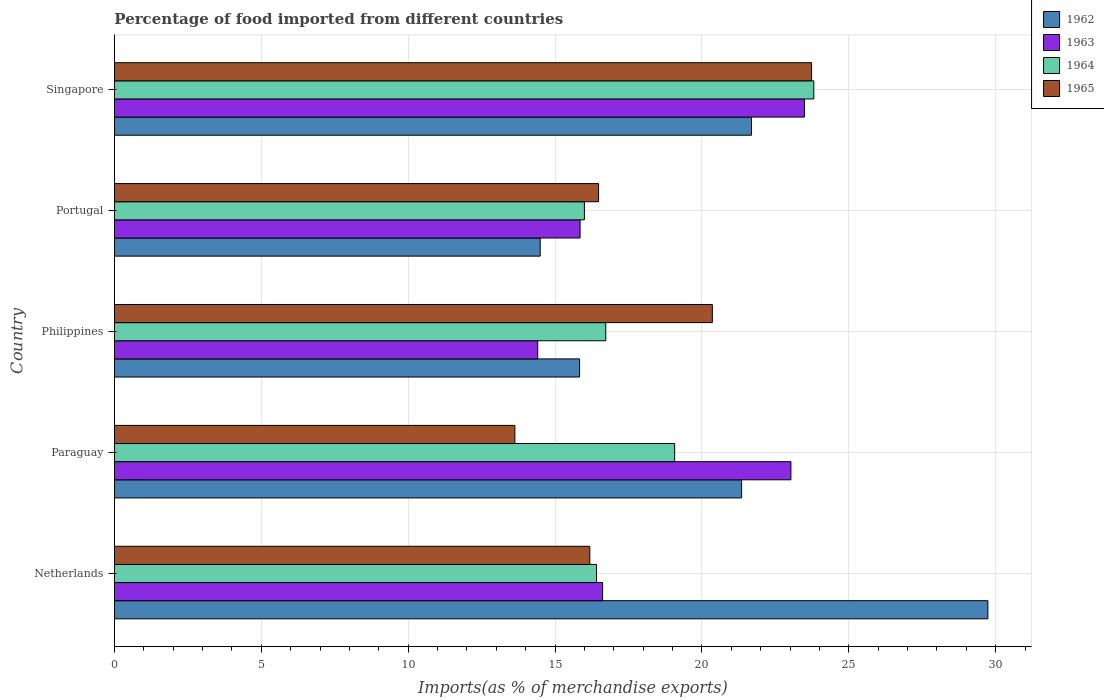How many different coloured bars are there?
Ensure brevity in your answer.  4. In how many cases, is the number of bars for a given country not equal to the number of legend labels?
Offer a very short reply. 0. What is the percentage of imports to different countries in 1964 in Paraguay?
Ensure brevity in your answer.  19.07. Across all countries, what is the maximum percentage of imports to different countries in 1963?
Make the answer very short. 23.49. Across all countries, what is the minimum percentage of imports to different countries in 1963?
Give a very brief answer. 14.41. In which country was the percentage of imports to different countries in 1965 minimum?
Your answer should be compact. Paraguay. What is the total percentage of imports to different countries in 1962 in the graph?
Provide a succinct answer. 103.1. What is the difference between the percentage of imports to different countries in 1963 in Philippines and that in Singapore?
Your answer should be compact. -9.08. What is the difference between the percentage of imports to different countries in 1962 in Paraguay and the percentage of imports to different countries in 1965 in Singapore?
Offer a very short reply. -2.38. What is the average percentage of imports to different countries in 1963 per country?
Your answer should be compact. 18.68. What is the difference between the percentage of imports to different countries in 1963 and percentage of imports to different countries in 1964 in Paraguay?
Provide a succinct answer. 3.96. In how many countries, is the percentage of imports to different countries in 1965 greater than 14 %?
Give a very brief answer. 4. What is the ratio of the percentage of imports to different countries in 1962 in Portugal to that in Singapore?
Your answer should be compact. 0.67. Is the percentage of imports to different countries in 1964 in Netherlands less than that in Portugal?
Your answer should be compact. No. Is the difference between the percentage of imports to different countries in 1963 in Netherlands and Philippines greater than the difference between the percentage of imports to different countries in 1964 in Netherlands and Philippines?
Keep it short and to the point. Yes. What is the difference between the highest and the second highest percentage of imports to different countries in 1963?
Provide a short and direct response. 0.46. What is the difference between the highest and the lowest percentage of imports to different countries in 1965?
Provide a succinct answer. 10.1. In how many countries, is the percentage of imports to different countries in 1962 greater than the average percentage of imports to different countries in 1962 taken over all countries?
Your answer should be very brief. 3. Is it the case that in every country, the sum of the percentage of imports to different countries in 1964 and percentage of imports to different countries in 1963 is greater than the sum of percentage of imports to different countries in 1965 and percentage of imports to different countries in 1962?
Your answer should be very brief. No. What does the 1st bar from the top in Paraguay represents?
Provide a short and direct response. 1965. What does the 4th bar from the bottom in Paraguay represents?
Your response must be concise. 1965. How many bars are there?
Provide a succinct answer. 20. Are all the bars in the graph horizontal?
Your answer should be very brief. Yes. What is the difference between two consecutive major ticks on the X-axis?
Provide a succinct answer. 5. Does the graph contain any zero values?
Provide a short and direct response. No. Does the graph contain grids?
Offer a terse response. Yes. Where does the legend appear in the graph?
Offer a terse response. Top right. What is the title of the graph?
Your response must be concise. Percentage of food imported from different countries. What is the label or title of the X-axis?
Provide a short and direct response. Imports(as % of merchandise exports). What is the label or title of the Y-axis?
Provide a succinct answer. Country. What is the Imports(as % of merchandise exports) in 1962 in Netherlands?
Your answer should be compact. 29.73. What is the Imports(as % of merchandise exports) of 1963 in Netherlands?
Ensure brevity in your answer.  16.62. What is the Imports(as % of merchandise exports) of 1964 in Netherlands?
Offer a very short reply. 16.41. What is the Imports(as % of merchandise exports) of 1965 in Netherlands?
Give a very brief answer. 16.18. What is the Imports(as % of merchandise exports) in 1962 in Paraguay?
Give a very brief answer. 21.35. What is the Imports(as % of merchandise exports) in 1963 in Paraguay?
Ensure brevity in your answer.  23.03. What is the Imports(as % of merchandise exports) of 1964 in Paraguay?
Give a very brief answer. 19.07. What is the Imports(as % of merchandise exports) in 1965 in Paraguay?
Provide a succinct answer. 13.63. What is the Imports(as % of merchandise exports) in 1962 in Philippines?
Your answer should be very brief. 15.83. What is the Imports(as % of merchandise exports) of 1963 in Philippines?
Provide a succinct answer. 14.41. What is the Imports(as % of merchandise exports) in 1964 in Philippines?
Give a very brief answer. 16.73. What is the Imports(as % of merchandise exports) in 1965 in Philippines?
Provide a short and direct response. 20.35. What is the Imports(as % of merchandise exports) of 1962 in Portugal?
Make the answer very short. 14.49. What is the Imports(as % of merchandise exports) of 1963 in Portugal?
Your response must be concise. 15.85. What is the Imports(as % of merchandise exports) in 1964 in Portugal?
Keep it short and to the point. 16. What is the Imports(as % of merchandise exports) of 1965 in Portugal?
Offer a very short reply. 16.48. What is the Imports(as % of merchandise exports) of 1962 in Singapore?
Provide a succinct answer. 21.69. What is the Imports(as % of merchandise exports) of 1963 in Singapore?
Your answer should be compact. 23.49. What is the Imports(as % of merchandise exports) of 1964 in Singapore?
Offer a terse response. 23.81. What is the Imports(as % of merchandise exports) in 1965 in Singapore?
Your response must be concise. 23.73. Across all countries, what is the maximum Imports(as % of merchandise exports) of 1962?
Provide a succinct answer. 29.73. Across all countries, what is the maximum Imports(as % of merchandise exports) in 1963?
Your response must be concise. 23.49. Across all countries, what is the maximum Imports(as % of merchandise exports) in 1964?
Your response must be concise. 23.81. Across all countries, what is the maximum Imports(as % of merchandise exports) of 1965?
Your response must be concise. 23.73. Across all countries, what is the minimum Imports(as % of merchandise exports) of 1962?
Keep it short and to the point. 14.49. Across all countries, what is the minimum Imports(as % of merchandise exports) in 1963?
Keep it short and to the point. 14.41. Across all countries, what is the minimum Imports(as % of merchandise exports) in 1964?
Give a very brief answer. 16. Across all countries, what is the minimum Imports(as % of merchandise exports) in 1965?
Provide a succinct answer. 13.63. What is the total Imports(as % of merchandise exports) of 1962 in the graph?
Your response must be concise. 103.1. What is the total Imports(as % of merchandise exports) in 1963 in the graph?
Your response must be concise. 93.4. What is the total Imports(as % of merchandise exports) in 1964 in the graph?
Keep it short and to the point. 92.02. What is the total Imports(as % of merchandise exports) in 1965 in the graph?
Your answer should be compact. 90.38. What is the difference between the Imports(as % of merchandise exports) in 1962 in Netherlands and that in Paraguay?
Your answer should be compact. 8.38. What is the difference between the Imports(as % of merchandise exports) of 1963 in Netherlands and that in Paraguay?
Your answer should be very brief. -6.41. What is the difference between the Imports(as % of merchandise exports) in 1964 in Netherlands and that in Paraguay?
Offer a very short reply. -2.66. What is the difference between the Imports(as % of merchandise exports) of 1965 in Netherlands and that in Paraguay?
Provide a short and direct response. 2.55. What is the difference between the Imports(as % of merchandise exports) in 1962 in Netherlands and that in Philippines?
Your answer should be very brief. 13.9. What is the difference between the Imports(as % of merchandise exports) in 1963 in Netherlands and that in Philippines?
Keep it short and to the point. 2.21. What is the difference between the Imports(as % of merchandise exports) in 1964 in Netherlands and that in Philippines?
Provide a succinct answer. -0.31. What is the difference between the Imports(as % of merchandise exports) in 1965 in Netherlands and that in Philippines?
Your answer should be very brief. -4.17. What is the difference between the Imports(as % of merchandise exports) in 1962 in Netherlands and that in Portugal?
Make the answer very short. 15.24. What is the difference between the Imports(as % of merchandise exports) of 1963 in Netherlands and that in Portugal?
Ensure brevity in your answer.  0.77. What is the difference between the Imports(as % of merchandise exports) of 1964 in Netherlands and that in Portugal?
Provide a short and direct response. 0.41. What is the difference between the Imports(as % of merchandise exports) in 1965 in Netherlands and that in Portugal?
Offer a very short reply. -0.3. What is the difference between the Imports(as % of merchandise exports) in 1962 in Netherlands and that in Singapore?
Your answer should be very brief. 8.05. What is the difference between the Imports(as % of merchandise exports) in 1963 in Netherlands and that in Singapore?
Give a very brief answer. -6.87. What is the difference between the Imports(as % of merchandise exports) of 1964 in Netherlands and that in Singapore?
Offer a very short reply. -7.4. What is the difference between the Imports(as % of merchandise exports) of 1965 in Netherlands and that in Singapore?
Keep it short and to the point. -7.55. What is the difference between the Imports(as % of merchandise exports) in 1962 in Paraguay and that in Philippines?
Offer a terse response. 5.52. What is the difference between the Imports(as % of merchandise exports) of 1963 in Paraguay and that in Philippines?
Make the answer very short. 8.62. What is the difference between the Imports(as % of merchandise exports) in 1964 in Paraguay and that in Philippines?
Offer a very short reply. 2.35. What is the difference between the Imports(as % of merchandise exports) of 1965 in Paraguay and that in Philippines?
Your answer should be very brief. -6.72. What is the difference between the Imports(as % of merchandise exports) of 1962 in Paraguay and that in Portugal?
Ensure brevity in your answer.  6.86. What is the difference between the Imports(as % of merchandise exports) in 1963 in Paraguay and that in Portugal?
Offer a terse response. 7.18. What is the difference between the Imports(as % of merchandise exports) in 1964 in Paraguay and that in Portugal?
Your response must be concise. 3.07. What is the difference between the Imports(as % of merchandise exports) of 1965 in Paraguay and that in Portugal?
Keep it short and to the point. -2.85. What is the difference between the Imports(as % of merchandise exports) in 1962 in Paraguay and that in Singapore?
Your answer should be very brief. -0.34. What is the difference between the Imports(as % of merchandise exports) of 1963 in Paraguay and that in Singapore?
Make the answer very short. -0.46. What is the difference between the Imports(as % of merchandise exports) of 1964 in Paraguay and that in Singapore?
Provide a short and direct response. -4.74. What is the difference between the Imports(as % of merchandise exports) of 1965 in Paraguay and that in Singapore?
Your response must be concise. -10.1. What is the difference between the Imports(as % of merchandise exports) of 1962 in Philippines and that in Portugal?
Make the answer very short. 1.34. What is the difference between the Imports(as % of merchandise exports) of 1963 in Philippines and that in Portugal?
Make the answer very short. -1.44. What is the difference between the Imports(as % of merchandise exports) of 1964 in Philippines and that in Portugal?
Make the answer very short. 0.73. What is the difference between the Imports(as % of merchandise exports) in 1965 in Philippines and that in Portugal?
Your answer should be very brief. 3.87. What is the difference between the Imports(as % of merchandise exports) of 1962 in Philippines and that in Singapore?
Provide a succinct answer. -5.85. What is the difference between the Imports(as % of merchandise exports) of 1963 in Philippines and that in Singapore?
Make the answer very short. -9.08. What is the difference between the Imports(as % of merchandise exports) of 1964 in Philippines and that in Singapore?
Offer a very short reply. -7.08. What is the difference between the Imports(as % of merchandise exports) of 1965 in Philippines and that in Singapore?
Keep it short and to the point. -3.38. What is the difference between the Imports(as % of merchandise exports) in 1962 in Portugal and that in Singapore?
Ensure brevity in your answer.  -7.19. What is the difference between the Imports(as % of merchandise exports) in 1963 in Portugal and that in Singapore?
Provide a short and direct response. -7.64. What is the difference between the Imports(as % of merchandise exports) in 1964 in Portugal and that in Singapore?
Provide a succinct answer. -7.81. What is the difference between the Imports(as % of merchandise exports) in 1965 in Portugal and that in Singapore?
Make the answer very short. -7.25. What is the difference between the Imports(as % of merchandise exports) in 1962 in Netherlands and the Imports(as % of merchandise exports) in 1963 in Paraguay?
Your response must be concise. 6.71. What is the difference between the Imports(as % of merchandise exports) of 1962 in Netherlands and the Imports(as % of merchandise exports) of 1964 in Paraguay?
Offer a terse response. 10.66. What is the difference between the Imports(as % of merchandise exports) in 1962 in Netherlands and the Imports(as % of merchandise exports) in 1965 in Paraguay?
Make the answer very short. 16.1. What is the difference between the Imports(as % of merchandise exports) in 1963 in Netherlands and the Imports(as % of merchandise exports) in 1964 in Paraguay?
Your answer should be very brief. -2.45. What is the difference between the Imports(as % of merchandise exports) in 1963 in Netherlands and the Imports(as % of merchandise exports) in 1965 in Paraguay?
Provide a succinct answer. 2.99. What is the difference between the Imports(as % of merchandise exports) of 1964 in Netherlands and the Imports(as % of merchandise exports) of 1965 in Paraguay?
Offer a terse response. 2.78. What is the difference between the Imports(as % of merchandise exports) in 1962 in Netherlands and the Imports(as % of merchandise exports) in 1963 in Philippines?
Offer a terse response. 15.32. What is the difference between the Imports(as % of merchandise exports) of 1962 in Netherlands and the Imports(as % of merchandise exports) of 1964 in Philippines?
Your answer should be compact. 13.01. What is the difference between the Imports(as % of merchandise exports) of 1962 in Netherlands and the Imports(as % of merchandise exports) of 1965 in Philippines?
Provide a succinct answer. 9.38. What is the difference between the Imports(as % of merchandise exports) in 1963 in Netherlands and the Imports(as % of merchandise exports) in 1964 in Philippines?
Provide a succinct answer. -0.11. What is the difference between the Imports(as % of merchandise exports) of 1963 in Netherlands and the Imports(as % of merchandise exports) of 1965 in Philippines?
Your response must be concise. -3.74. What is the difference between the Imports(as % of merchandise exports) of 1964 in Netherlands and the Imports(as % of merchandise exports) of 1965 in Philippines?
Provide a succinct answer. -3.94. What is the difference between the Imports(as % of merchandise exports) of 1962 in Netherlands and the Imports(as % of merchandise exports) of 1963 in Portugal?
Keep it short and to the point. 13.88. What is the difference between the Imports(as % of merchandise exports) of 1962 in Netherlands and the Imports(as % of merchandise exports) of 1964 in Portugal?
Provide a short and direct response. 13.74. What is the difference between the Imports(as % of merchandise exports) of 1962 in Netherlands and the Imports(as % of merchandise exports) of 1965 in Portugal?
Offer a very short reply. 13.25. What is the difference between the Imports(as % of merchandise exports) in 1963 in Netherlands and the Imports(as % of merchandise exports) in 1964 in Portugal?
Give a very brief answer. 0.62. What is the difference between the Imports(as % of merchandise exports) of 1963 in Netherlands and the Imports(as % of merchandise exports) of 1965 in Portugal?
Your response must be concise. 0.14. What is the difference between the Imports(as % of merchandise exports) of 1964 in Netherlands and the Imports(as % of merchandise exports) of 1965 in Portugal?
Keep it short and to the point. -0.07. What is the difference between the Imports(as % of merchandise exports) of 1962 in Netherlands and the Imports(as % of merchandise exports) of 1963 in Singapore?
Your answer should be very brief. 6.25. What is the difference between the Imports(as % of merchandise exports) in 1962 in Netherlands and the Imports(as % of merchandise exports) in 1964 in Singapore?
Offer a terse response. 5.93. What is the difference between the Imports(as % of merchandise exports) in 1962 in Netherlands and the Imports(as % of merchandise exports) in 1965 in Singapore?
Keep it short and to the point. 6. What is the difference between the Imports(as % of merchandise exports) in 1963 in Netherlands and the Imports(as % of merchandise exports) in 1964 in Singapore?
Offer a very short reply. -7.19. What is the difference between the Imports(as % of merchandise exports) of 1963 in Netherlands and the Imports(as % of merchandise exports) of 1965 in Singapore?
Your answer should be very brief. -7.11. What is the difference between the Imports(as % of merchandise exports) of 1964 in Netherlands and the Imports(as % of merchandise exports) of 1965 in Singapore?
Offer a terse response. -7.32. What is the difference between the Imports(as % of merchandise exports) in 1962 in Paraguay and the Imports(as % of merchandise exports) in 1963 in Philippines?
Offer a terse response. 6.94. What is the difference between the Imports(as % of merchandise exports) of 1962 in Paraguay and the Imports(as % of merchandise exports) of 1964 in Philippines?
Keep it short and to the point. 4.62. What is the difference between the Imports(as % of merchandise exports) in 1962 in Paraguay and the Imports(as % of merchandise exports) in 1965 in Philippines?
Offer a very short reply. 1. What is the difference between the Imports(as % of merchandise exports) in 1963 in Paraguay and the Imports(as % of merchandise exports) in 1964 in Philippines?
Your answer should be compact. 6.3. What is the difference between the Imports(as % of merchandise exports) of 1963 in Paraguay and the Imports(as % of merchandise exports) of 1965 in Philippines?
Offer a very short reply. 2.67. What is the difference between the Imports(as % of merchandise exports) in 1964 in Paraguay and the Imports(as % of merchandise exports) in 1965 in Philippines?
Keep it short and to the point. -1.28. What is the difference between the Imports(as % of merchandise exports) of 1962 in Paraguay and the Imports(as % of merchandise exports) of 1963 in Portugal?
Offer a terse response. 5.5. What is the difference between the Imports(as % of merchandise exports) of 1962 in Paraguay and the Imports(as % of merchandise exports) of 1964 in Portugal?
Provide a succinct answer. 5.35. What is the difference between the Imports(as % of merchandise exports) in 1962 in Paraguay and the Imports(as % of merchandise exports) in 1965 in Portugal?
Provide a succinct answer. 4.87. What is the difference between the Imports(as % of merchandise exports) of 1963 in Paraguay and the Imports(as % of merchandise exports) of 1964 in Portugal?
Provide a short and direct response. 7.03. What is the difference between the Imports(as % of merchandise exports) in 1963 in Paraguay and the Imports(as % of merchandise exports) in 1965 in Portugal?
Keep it short and to the point. 6.55. What is the difference between the Imports(as % of merchandise exports) of 1964 in Paraguay and the Imports(as % of merchandise exports) of 1965 in Portugal?
Your response must be concise. 2.59. What is the difference between the Imports(as % of merchandise exports) of 1962 in Paraguay and the Imports(as % of merchandise exports) of 1963 in Singapore?
Keep it short and to the point. -2.14. What is the difference between the Imports(as % of merchandise exports) in 1962 in Paraguay and the Imports(as % of merchandise exports) in 1964 in Singapore?
Keep it short and to the point. -2.46. What is the difference between the Imports(as % of merchandise exports) of 1962 in Paraguay and the Imports(as % of merchandise exports) of 1965 in Singapore?
Make the answer very short. -2.38. What is the difference between the Imports(as % of merchandise exports) of 1963 in Paraguay and the Imports(as % of merchandise exports) of 1964 in Singapore?
Your response must be concise. -0.78. What is the difference between the Imports(as % of merchandise exports) in 1963 in Paraguay and the Imports(as % of merchandise exports) in 1965 in Singapore?
Offer a very short reply. -0.7. What is the difference between the Imports(as % of merchandise exports) in 1964 in Paraguay and the Imports(as % of merchandise exports) in 1965 in Singapore?
Your answer should be compact. -4.66. What is the difference between the Imports(as % of merchandise exports) in 1962 in Philippines and the Imports(as % of merchandise exports) in 1963 in Portugal?
Ensure brevity in your answer.  -0.02. What is the difference between the Imports(as % of merchandise exports) of 1962 in Philippines and the Imports(as % of merchandise exports) of 1964 in Portugal?
Provide a short and direct response. -0.16. What is the difference between the Imports(as % of merchandise exports) in 1962 in Philippines and the Imports(as % of merchandise exports) in 1965 in Portugal?
Provide a short and direct response. -0.65. What is the difference between the Imports(as % of merchandise exports) in 1963 in Philippines and the Imports(as % of merchandise exports) in 1964 in Portugal?
Provide a short and direct response. -1.59. What is the difference between the Imports(as % of merchandise exports) of 1963 in Philippines and the Imports(as % of merchandise exports) of 1965 in Portugal?
Provide a succinct answer. -2.07. What is the difference between the Imports(as % of merchandise exports) in 1964 in Philippines and the Imports(as % of merchandise exports) in 1965 in Portugal?
Give a very brief answer. 0.24. What is the difference between the Imports(as % of merchandise exports) in 1962 in Philippines and the Imports(as % of merchandise exports) in 1963 in Singapore?
Your answer should be compact. -7.65. What is the difference between the Imports(as % of merchandise exports) in 1962 in Philippines and the Imports(as % of merchandise exports) in 1964 in Singapore?
Your answer should be compact. -7.97. What is the difference between the Imports(as % of merchandise exports) in 1962 in Philippines and the Imports(as % of merchandise exports) in 1965 in Singapore?
Offer a very short reply. -7.9. What is the difference between the Imports(as % of merchandise exports) of 1963 in Philippines and the Imports(as % of merchandise exports) of 1964 in Singapore?
Your answer should be compact. -9.4. What is the difference between the Imports(as % of merchandise exports) of 1963 in Philippines and the Imports(as % of merchandise exports) of 1965 in Singapore?
Your answer should be compact. -9.32. What is the difference between the Imports(as % of merchandise exports) of 1964 in Philippines and the Imports(as % of merchandise exports) of 1965 in Singapore?
Offer a very short reply. -7.01. What is the difference between the Imports(as % of merchandise exports) of 1962 in Portugal and the Imports(as % of merchandise exports) of 1963 in Singapore?
Provide a short and direct response. -8.99. What is the difference between the Imports(as % of merchandise exports) of 1962 in Portugal and the Imports(as % of merchandise exports) of 1964 in Singapore?
Ensure brevity in your answer.  -9.31. What is the difference between the Imports(as % of merchandise exports) in 1962 in Portugal and the Imports(as % of merchandise exports) in 1965 in Singapore?
Offer a terse response. -9.24. What is the difference between the Imports(as % of merchandise exports) of 1963 in Portugal and the Imports(as % of merchandise exports) of 1964 in Singapore?
Ensure brevity in your answer.  -7.96. What is the difference between the Imports(as % of merchandise exports) in 1963 in Portugal and the Imports(as % of merchandise exports) in 1965 in Singapore?
Your response must be concise. -7.88. What is the difference between the Imports(as % of merchandise exports) in 1964 in Portugal and the Imports(as % of merchandise exports) in 1965 in Singapore?
Offer a terse response. -7.73. What is the average Imports(as % of merchandise exports) in 1962 per country?
Your answer should be compact. 20.62. What is the average Imports(as % of merchandise exports) in 1963 per country?
Give a very brief answer. 18.68. What is the average Imports(as % of merchandise exports) of 1964 per country?
Your answer should be very brief. 18.4. What is the average Imports(as % of merchandise exports) in 1965 per country?
Provide a short and direct response. 18.08. What is the difference between the Imports(as % of merchandise exports) in 1962 and Imports(as % of merchandise exports) in 1963 in Netherlands?
Your response must be concise. 13.12. What is the difference between the Imports(as % of merchandise exports) of 1962 and Imports(as % of merchandise exports) of 1964 in Netherlands?
Your answer should be very brief. 13.32. What is the difference between the Imports(as % of merchandise exports) of 1962 and Imports(as % of merchandise exports) of 1965 in Netherlands?
Offer a very short reply. 13.55. What is the difference between the Imports(as % of merchandise exports) in 1963 and Imports(as % of merchandise exports) in 1964 in Netherlands?
Your answer should be very brief. 0.21. What is the difference between the Imports(as % of merchandise exports) of 1963 and Imports(as % of merchandise exports) of 1965 in Netherlands?
Offer a very short reply. 0.44. What is the difference between the Imports(as % of merchandise exports) of 1964 and Imports(as % of merchandise exports) of 1965 in Netherlands?
Provide a short and direct response. 0.23. What is the difference between the Imports(as % of merchandise exports) of 1962 and Imports(as % of merchandise exports) of 1963 in Paraguay?
Offer a very short reply. -1.68. What is the difference between the Imports(as % of merchandise exports) of 1962 and Imports(as % of merchandise exports) of 1964 in Paraguay?
Make the answer very short. 2.28. What is the difference between the Imports(as % of merchandise exports) in 1962 and Imports(as % of merchandise exports) in 1965 in Paraguay?
Your answer should be compact. 7.72. What is the difference between the Imports(as % of merchandise exports) of 1963 and Imports(as % of merchandise exports) of 1964 in Paraguay?
Ensure brevity in your answer.  3.96. What is the difference between the Imports(as % of merchandise exports) of 1963 and Imports(as % of merchandise exports) of 1965 in Paraguay?
Your answer should be compact. 9.4. What is the difference between the Imports(as % of merchandise exports) in 1964 and Imports(as % of merchandise exports) in 1965 in Paraguay?
Offer a very short reply. 5.44. What is the difference between the Imports(as % of merchandise exports) of 1962 and Imports(as % of merchandise exports) of 1963 in Philippines?
Your answer should be very brief. 1.43. What is the difference between the Imports(as % of merchandise exports) in 1962 and Imports(as % of merchandise exports) in 1964 in Philippines?
Provide a succinct answer. -0.89. What is the difference between the Imports(as % of merchandise exports) of 1962 and Imports(as % of merchandise exports) of 1965 in Philippines?
Your answer should be compact. -4.52. What is the difference between the Imports(as % of merchandise exports) in 1963 and Imports(as % of merchandise exports) in 1964 in Philippines?
Ensure brevity in your answer.  -2.32. What is the difference between the Imports(as % of merchandise exports) of 1963 and Imports(as % of merchandise exports) of 1965 in Philippines?
Offer a terse response. -5.94. What is the difference between the Imports(as % of merchandise exports) in 1964 and Imports(as % of merchandise exports) in 1965 in Philippines?
Make the answer very short. -3.63. What is the difference between the Imports(as % of merchandise exports) of 1962 and Imports(as % of merchandise exports) of 1963 in Portugal?
Keep it short and to the point. -1.36. What is the difference between the Imports(as % of merchandise exports) in 1962 and Imports(as % of merchandise exports) in 1964 in Portugal?
Your response must be concise. -1.5. What is the difference between the Imports(as % of merchandise exports) in 1962 and Imports(as % of merchandise exports) in 1965 in Portugal?
Provide a succinct answer. -1.99. What is the difference between the Imports(as % of merchandise exports) in 1963 and Imports(as % of merchandise exports) in 1964 in Portugal?
Keep it short and to the point. -0.15. What is the difference between the Imports(as % of merchandise exports) in 1963 and Imports(as % of merchandise exports) in 1965 in Portugal?
Your answer should be very brief. -0.63. What is the difference between the Imports(as % of merchandise exports) in 1964 and Imports(as % of merchandise exports) in 1965 in Portugal?
Give a very brief answer. -0.48. What is the difference between the Imports(as % of merchandise exports) in 1962 and Imports(as % of merchandise exports) in 1963 in Singapore?
Your answer should be very brief. -1.8. What is the difference between the Imports(as % of merchandise exports) in 1962 and Imports(as % of merchandise exports) in 1964 in Singapore?
Keep it short and to the point. -2.12. What is the difference between the Imports(as % of merchandise exports) of 1962 and Imports(as % of merchandise exports) of 1965 in Singapore?
Provide a succinct answer. -2.04. What is the difference between the Imports(as % of merchandise exports) of 1963 and Imports(as % of merchandise exports) of 1964 in Singapore?
Keep it short and to the point. -0.32. What is the difference between the Imports(as % of merchandise exports) of 1963 and Imports(as % of merchandise exports) of 1965 in Singapore?
Offer a very short reply. -0.24. What is the difference between the Imports(as % of merchandise exports) of 1964 and Imports(as % of merchandise exports) of 1965 in Singapore?
Give a very brief answer. 0.08. What is the ratio of the Imports(as % of merchandise exports) in 1962 in Netherlands to that in Paraguay?
Offer a very short reply. 1.39. What is the ratio of the Imports(as % of merchandise exports) of 1963 in Netherlands to that in Paraguay?
Make the answer very short. 0.72. What is the ratio of the Imports(as % of merchandise exports) in 1964 in Netherlands to that in Paraguay?
Your response must be concise. 0.86. What is the ratio of the Imports(as % of merchandise exports) of 1965 in Netherlands to that in Paraguay?
Ensure brevity in your answer.  1.19. What is the ratio of the Imports(as % of merchandise exports) in 1962 in Netherlands to that in Philippines?
Your response must be concise. 1.88. What is the ratio of the Imports(as % of merchandise exports) of 1963 in Netherlands to that in Philippines?
Make the answer very short. 1.15. What is the ratio of the Imports(as % of merchandise exports) of 1964 in Netherlands to that in Philippines?
Your response must be concise. 0.98. What is the ratio of the Imports(as % of merchandise exports) in 1965 in Netherlands to that in Philippines?
Your answer should be compact. 0.8. What is the ratio of the Imports(as % of merchandise exports) in 1962 in Netherlands to that in Portugal?
Your answer should be very brief. 2.05. What is the ratio of the Imports(as % of merchandise exports) in 1963 in Netherlands to that in Portugal?
Keep it short and to the point. 1.05. What is the ratio of the Imports(as % of merchandise exports) in 1964 in Netherlands to that in Portugal?
Offer a terse response. 1.03. What is the ratio of the Imports(as % of merchandise exports) in 1965 in Netherlands to that in Portugal?
Give a very brief answer. 0.98. What is the ratio of the Imports(as % of merchandise exports) of 1962 in Netherlands to that in Singapore?
Give a very brief answer. 1.37. What is the ratio of the Imports(as % of merchandise exports) of 1963 in Netherlands to that in Singapore?
Make the answer very short. 0.71. What is the ratio of the Imports(as % of merchandise exports) in 1964 in Netherlands to that in Singapore?
Ensure brevity in your answer.  0.69. What is the ratio of the Imports(as % of merchandise exports) of 1965 in Netherlands to that in Singapore?
Give a very brief answer. 0.68. What is the ratio of the Imports(as % of merchandise exports) of 1962 in Paraguay to that in Philippines?
Keep it short and to the point. 1.35. What is the ratio of the Imports(as % of merchandise exports) in 1963 in Paraguay to that in Philippines?
Provide a short and direct response. 1.6. What is the ratio of the Imports(as % of merchandise exports) of 1964 in Paraguay to that in Philippines?
Provide a short and direct response. 1.14. What is the ratio of the Imports(as % of merchandise exports) of 1965 in Paraguay to that in Philippines?
Give a very brief answer. 0.67. What is the ratio of the Imports(as % of merchandise exports) in 1962 in Paraguay to that in Portugal?
Keep it short and to the point. 1.47. What is the ratio of the Imports(as % of merchandise exports) of 1963 in Paraguay to that in Portugal?
Provide a short and direct response. 1.45. What is the ratio of the Imports(as % of merchandise exports) in 1964 in Paraguay to that in Portugal?
Offer a terse response. 1.19. What is the ratio of the Imports(as % of merchandise exports) of 1965 in Paraguay to that in Portugal?
Your response must be concise. 0.83. What is the ratio of the Imports(as % of merchandise exports) in 1962 in Paraguay to that in Singapore?
Your response must be concise. 0.98. What is the ratio of the Imports(as % of merchandise exports) in 1963 in Paraguay to that in Singapore?
Offer a terse response. 0.98. What is the ratio of the Imports(as % of merchandise exports) in 1964 in Paraguay to that in Singapore?
Offer a terse response. 0.8. What is the ratio of the Imports(as % of merchandise exports) in 1965 in Paraguay to that in Singapore?
Offer a very short reply. 0.57. What is the ratio of the Imports(as % of merchandise exports) of 1962 in Philippines to that in Portugal?
Your answer should be compact. 1.09. What is the ratio of the Imports(as % of merchandise exports) of 1963 in Philippines to that in Portugal?
Your answer should be very brief. 0.91. What is the ratio of the Imports(as % of merchandise exports) in 1964 in Philippines to that in Portugal?
Provide a succinct answer. 1.05. What is the ratio of the Imports(as % of merchandise exports) of 1965 in Philippines to that in Portugal?
Keep it short and to the point. 1.24. What is the ratio of the Imports(as % of merchandise exports) of 1962 in Philippines to that in Singapore?
Keep it short and to the point. 0.73. What is the ratio of the Imports(as % of merchandise exports) of 1963 in Philippines to that in Singapore?
Your response must be concise. 0.61. What is the ratio of the Imports(as % of merchandise exports) of 1964 in Philippines to that in Singapore?
Make the answer very short. 0.7. What is the ratio of the Imports(as % of merchandise exports) in 1965 in Philippines to that in Singapore?
Provide a succinct answer. 0.86. What is the ratio of the Imports(as % of merchandise exports) in 1962 in Portugal to that in Singapore?
Offer a terse response. 0.67. What is the ratio of the Imports(as % of merchandise exports) of 1963 in Portugal to that in Singapore?
Offer a terse response. 0.67. What is the ratio of the Imports(as % of merchandise exports) in 1964 in Portugal to that in Singapore?
Provide a succinct answer. 0.67. What is the ratio of the Imports(as % of merchandise exports) of 1965 in Portugal to that in Singapore?
Offer a very short reply. 0.69. What is the difference between the highest and the second highest Imports(as % of merchandise exports) in 1962?
Offer a terse response. 8.05. What is the difference between the highest and the second highest Imports(as % of merchandise exports) in 1963?
Your response must be concise. 0.46. What is the difference between the highest and the second highest Imports(as % of merchandise exports) of 1964?
Your answer should be very brief. 4.74. What is the difference between the highest and the second highest Imports(as % of merchandise exports) in 1965?
Offer a terse response. 3.38. What is the difference between the highest and the lowest Imports(as % of merchandise exports) in 1962?
Your answer should be very brief. 15.24. What is the difference between the highest and the lowest Imports(as % of merchandise exports) in 1963?
Your answer should be compact. 9.08. What is the difference between the highest and the lowest Imports(as % of merchandise exports) in 1964?
Give a very brief answer. 7.81. What is the difference between the highest and the lowest Imports(as % of merchandise exports) in 1965?
Your response must be concise. 10.1. 